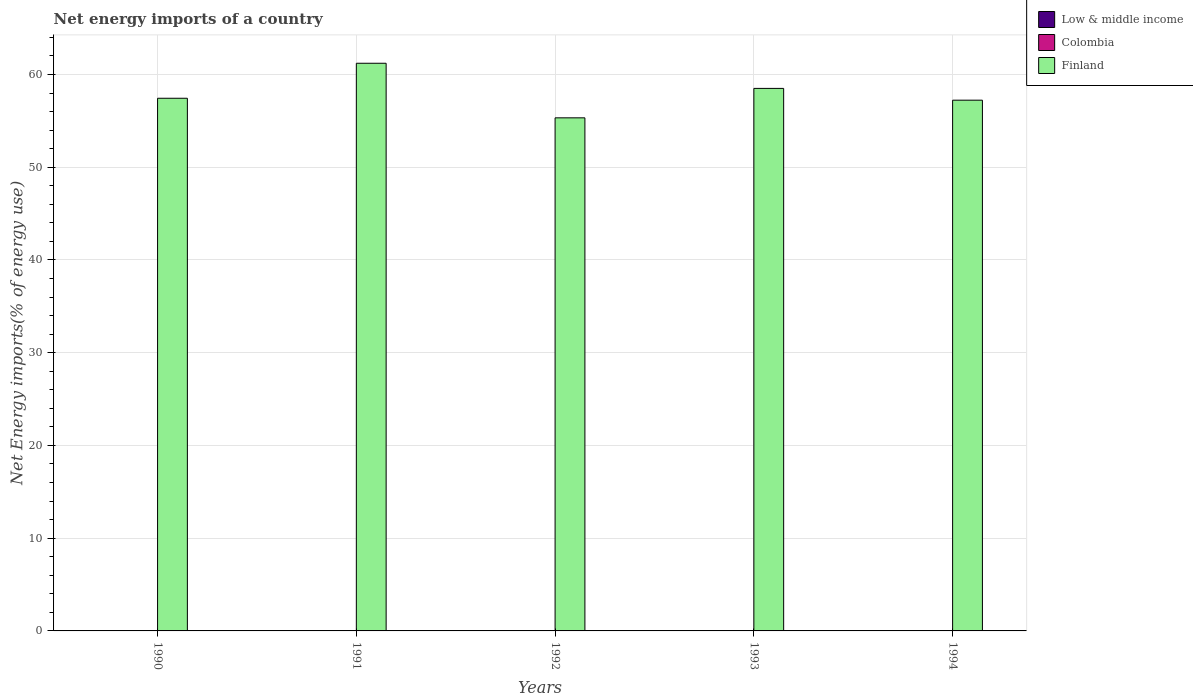Are the number of bars on each tick of the X-axis equal?
Ensure brevity in your answer.  Yes. How many bars are there on the 5th tick from the left?
Your response must be concise. 1. What is the label of the 4th group of bars from the left?
Your response must be concise. 1993. In how many cases, is the number of bars for a given year not equal to the number of legend labels?
Give a very brief answer. 5. Across all years, what is the maximum net energy imports in Finland?
Your answer should be very brief. 61.21. Across all years, what is the minimum net energy imports in Low & middle income?
Provide a succinct answer. 0. In which year was the net energy imports in Finland maximum?
Ensure brevity in your answer.  1991. What is the difference between the net energy imports in Finland in 1993 and that in 1994?
Keep it short and to the point. 1.27. What is the difference between the net energy imports in Colombia in 1992 and the net energy imports in Low & middle income in 1990?
Make the answer very short. 0. What is the average net energy imports in Finland per year?
Provide a short and direct response. 57.94. What is the ratio of the net energy imports in Finland in 1990 to that in 1994?
Ensure brevity in your answer.  1. What is the difference between the highest and the second highest net energy imports in Finland?
Offer a terse response. 2.71. What is the difference between the highest and the lowest net energy imports in Finland?
Your answer should be compact. 5.89. Is the sum of the net energy imports in Finland in 1990 and 1991 greater than the maximum net energy imports in Low & middle income across all years?
Provide a succinct answer. Yes. How many bars are there?
Keep it short and to the point. 5. How many years are there in the graph?
Offer a very short reply. 5. What is the difference between two consecutive major ticks on the Y-axis?
Provide a short and direct response. 10. Does the graph contain any zero values?
Provide a succinct answer. Yes. How many legend labels are there?
Offer a very short reply. 3. What is the title of the graph?
Make the answer very short. Net energy imports of a country. Does "Trinidad and Tobago" appear as one of the legend labels in the graph?
Ensure brevity in your answer.  No. What is the label or title of the X-axis?
Your answer should be compact. Years. What is the label or title of the Y-axis?
Offer a very short reply. Net Energy imports(% of energy use). What is the Net Energy imports(% of energy use) in Colombia in 1990?
Your answer should be compact. 0. What is the Net Energy imports(% of energy use) of Finland in 1990?
Provide a short and direct response. 57.43. What is the Net Energy imports(% of energy use) in Low & middle income in 1991?
Provide a succinct answer. 0. What is the Net Energy imports(% of energy use) of Finland in 1991?
Your answer should be compact. 61.21. What is the Net Energy imports(% of energy use) of Colombia in 1992?
Make the answer very short. 0. What is the Net Energy imports(% of energy use) of Finland in 1992?
Give a very brief answer. 55.32. What is the Net Energy imports(% of energy use) of Low & middle income in 1993?
Provide a short and direct response. 0. What is the Net Energy imports(% of energy use) in Finland in 1993?
Your answer should be compact. 58.5. What is the Net Energy imports(% of energy use) of Colombia in 1994?
Offer a terse response. 0. What is the Net Energy imports(% of energy use) of Finland in 1994?
Offer a very short reply. 57.23. Across all years, what is the maximum Net Energy imports(% of energy use) of Finland?
Keep it short and to the point. 61.21. Across all years, what is the minimum Net Energy imports(% of energy use) in Finland?
Your answer should be very brief. 55.32. What is the total Net Energy imports(% of energy use) in Finland in the graph?
Provide a succinct answer. 289.68. What is the difference between the Net Energy imports(% of energy use) of Finland in 1990 and that in 1991?
Your response must be concise. -3.77. What is the difference between the Net Energy imports(% of energy use) of Finland in 1990 and that in 1992?
Provide a succinct answer. 2.11. What is the difference between the Net Energy imports(% of energy use) of Finland in 1990 and that in 1993?
Your response must be concise. -1.06. What is the difference between the Net Energy imports(% of energy use) of Finland in 1990 and that in 1994?
Provide a succinct answer. 0.21. What is the difference between the Net Energy imports(% of energy use) of Finland in 1991 and that in 1992?
Make the answer very short. 5.89. What is the difference between the Net Energy imports(% of energy use) of Finland in 1991 and that in 1993?
Offer a terse response. 2.71. What is the difference between the Net Energy imports(% of energy use) in Finland in 1991 and that in 1994?
Make the answer very short. 3.98. What is the difference between the Net Energy imports(% of energy use) in Finland in 1992 and that in 1993?
Provide a short and direct response. -3.17. What is the difference between the Net Energy imports(% of energy use) in Finland in 1992 and that in 1994?
Keep it short and to the point. -1.9. What is the difference between the Net Energy imports(% of energy use) in Finland in 1993 and that in 1994?
Provide a succinct answer. 1.27. What is the average Net Energy imports(% of energy use) in Low & middle income per year?
Offer a terse response. 0. What is the average Net Energy imports(% of energy use) in Colombia per year?
Ensure brevity in your answer.  0. What is the average Net Energy imports(% of energy use) of Finland per year?
Ensure brevity in your answer.  57.94. What is the ratio of the Net Energy imports(% of energy use) in Finland in 1990 to that in 1991?
Keep it short and to the point. 0.94. What is the ratio of the Net Energy imports(% of energy use) of Finland in 1990 to that in 1992?
Offer a very short reply. 1.04. What is the ratio of the Net Energy imports(% of energy use) in Finland in 1990 to that in 1993?
Provide a succinct answer. 0.98. What is the ratio of the Net Energy imports(% of energy use) of Finland in 1990 to that in 1994?
Your response must be concise. 1. What is the ratio of the Net Energy imports(% of energy use) of Finland in 1991 to that in 1992?
Make the answer very short. 1.11. What is the ratio of the Net Energy imports(% of energy use) in Finland in 1991 to that in 1993?
Your answer should be compact. 1.05. What is the ratio of the Net Energy imports(% of energy use) in Finland in 1991 to that in 1994?
Ensure brevity in your answer.  1.07. What is the ratio of the Net Energy imports(% of energy use) of Finland in 1992 to that in 1993?
Ensure brevity in your answer.  0.95. What is the ratio of the Net Energy imports(% of energy use) in Finland in 1992 to that in 1994?
Make the answer very short. 0.97. What is the ratio of the Net Energy imports(% of energy use) in Finland in 1993 to that in 1994?
Provide a succinct answer. 1.02. What is the difference between the highest and the second highest Net Energy imports(% of energy use) of Finland?
Make the answer very short. 2.71. What is the difference between the highest and the lowest Net Energy imports(% of energy use) in Finland?
Your response must be concise. 5.89. 